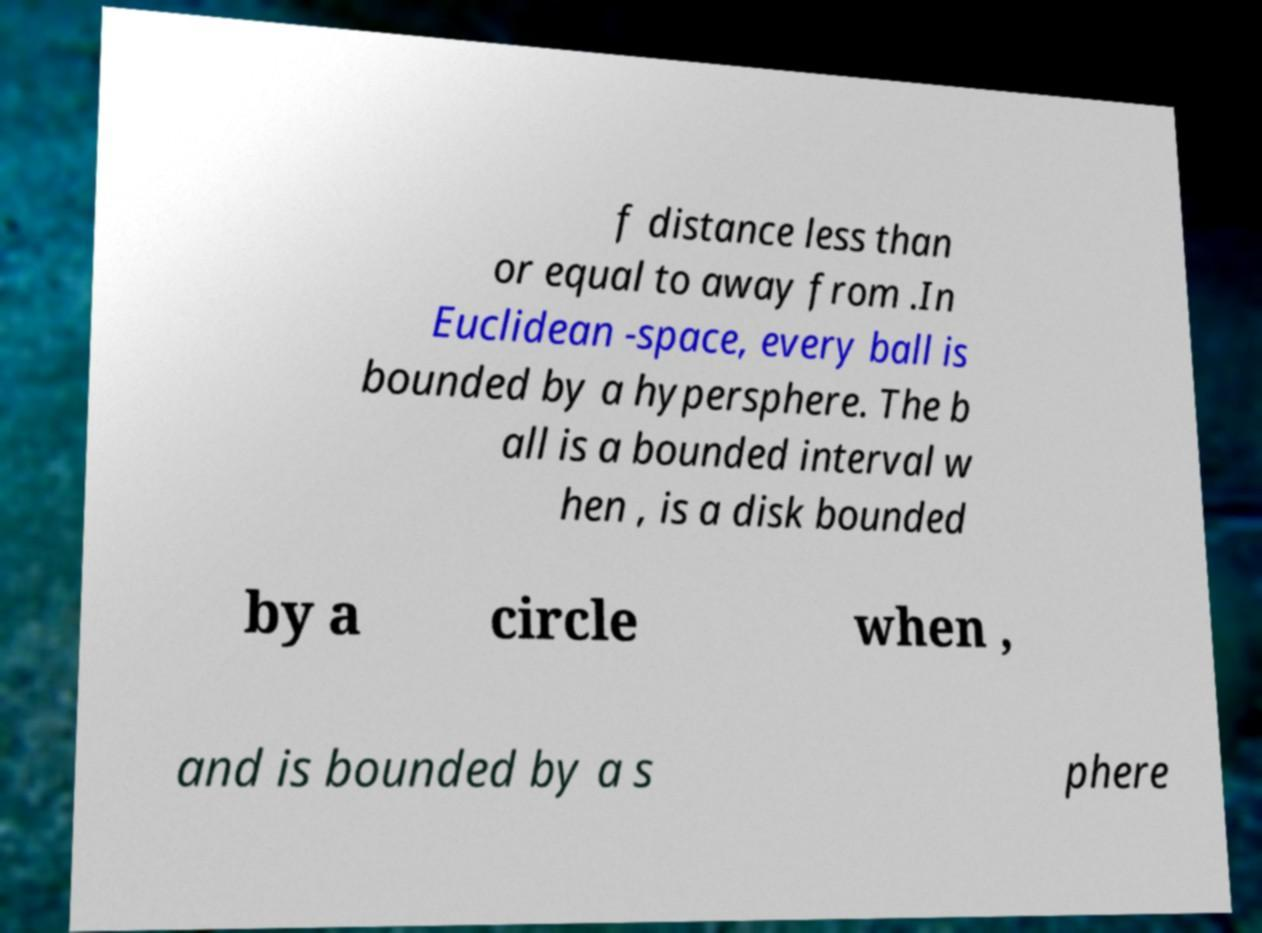Please identify and transcribe the text found in this image. f distance less than or equal to away from .In Euclidean -space, every ball is bounded by a hypersphere. The b all is a bounded interval w hen , is a disk bounded by a circle when , and is bounded by a s phere 